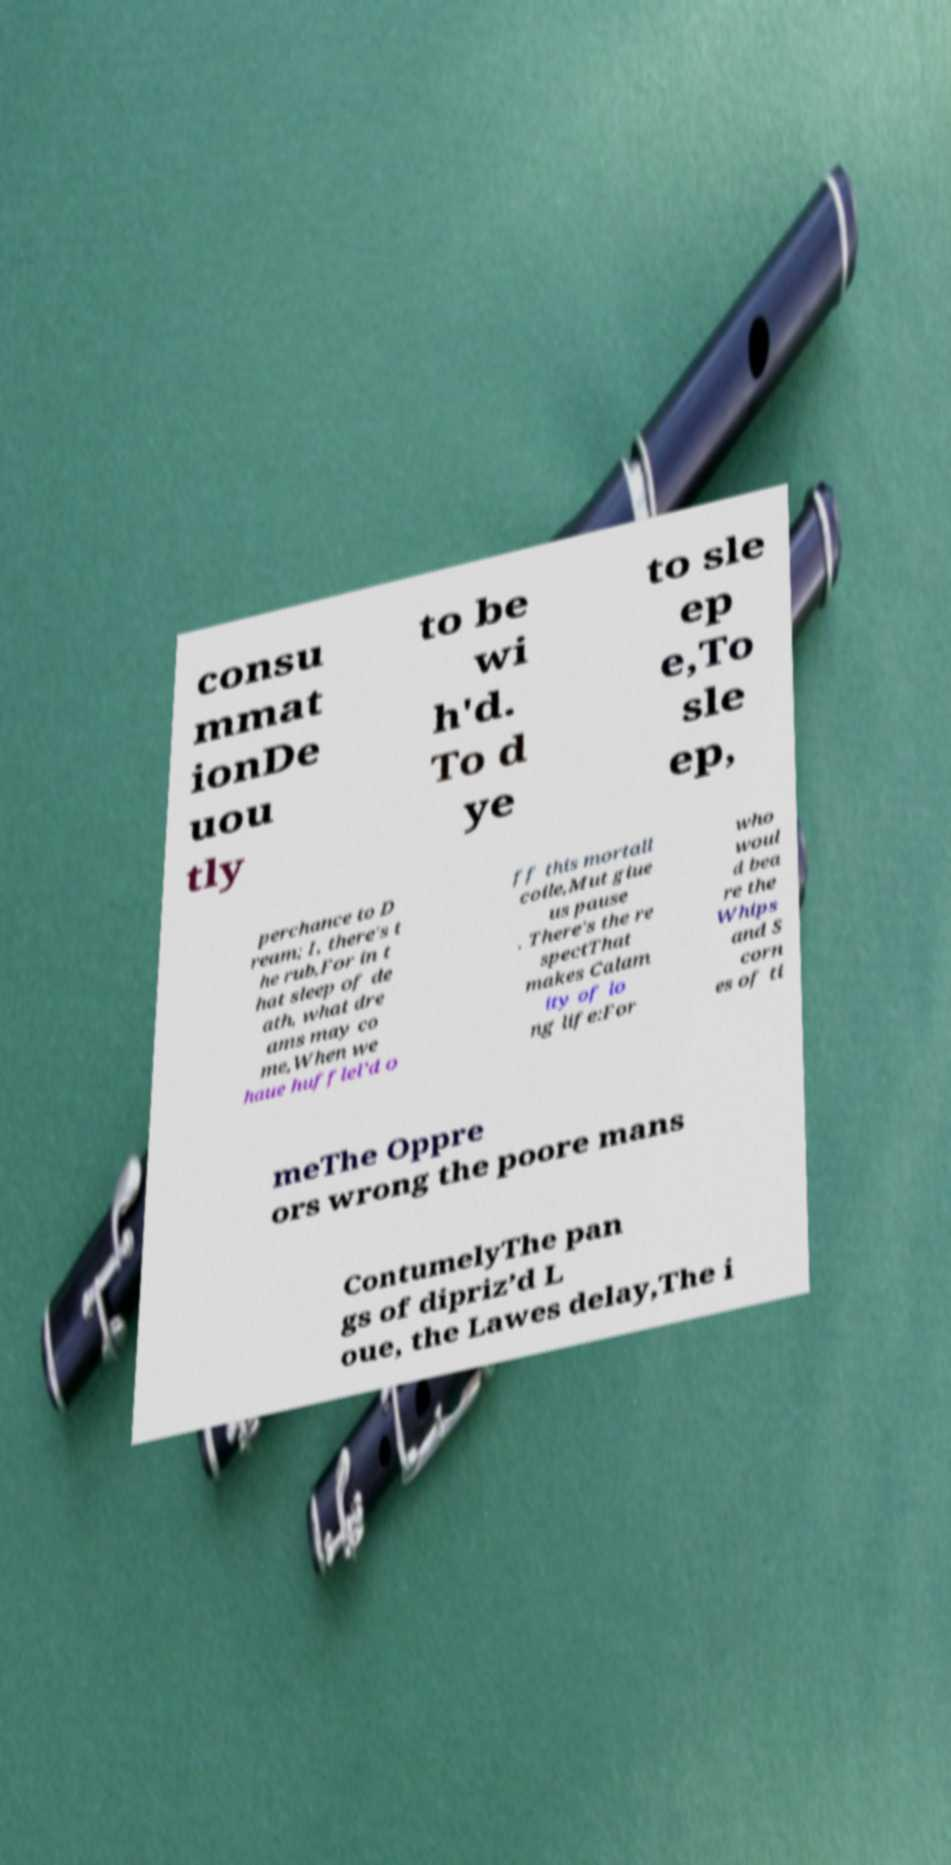What messages or text are displayed in this image? I need them in a readable, typed format. consu mmat ionDe uou tly to be wi h'd. To d ye to sle ep e,To sle ep, perchance to D ream; I, there's t he rub,For in t hat sleep of de ath, what dre ams may co me,When we haue hufflel’d o ff this mortall coile,Mut giue us pause . There's the re spectThat makes Calam ity of lo ng life:For who woul d bea re the Whips and S corn es of ti meThe Oppre ors wrong the poore mans ContumelyThe pan gs of dipriz’d L oue, the Lawes delay,The i 